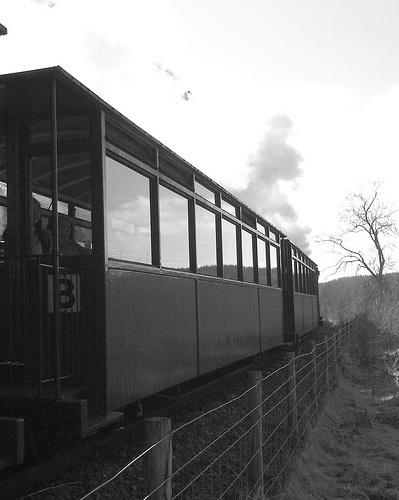Are there both cars and windows in the photograph?
Answer the question using a single word or phrase. Yes Are there both a door and a window in this scene? No What vehicle isn't black? Car What is the person in? Window 